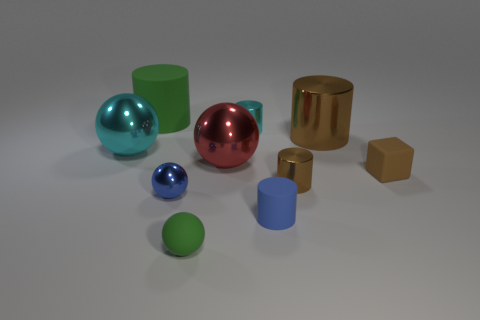What is the material of the cylinder that is to the left of the small green rubber sphere that is to the left of the small cyan metallic cylinder?
Provide a succinct answer. Rubber. Do the green object that is behind the big cyan metal object and the big cyan object have the same material?
Your answer should be compact. No. What is the size of the green matte object behind the cube?
Offer a terse response. Large. Is there a tiny green rubber sphere that is left of the shiny sphere in front of the red shiny ball?
Provide a succinct answer. No. There is a large thing that is to the right of the blue cylinder; is it the same color as the tiny ball in front of the small blue shiny object?
Offer a very short reply. No. The cube has what color?
Keep it short and to the point. Brown. Are there any other things of the same color as the rubber ball?
Your response must be concise. Yes. What color is the small thing that is both behind the tiny green matte object and in front of the blue metallic thing?
Your answer should be very brief. Blue. Does the cylinder that is on the left side of the matte ball have the same size as the large cyan object?
Keep it short and to the point. Yes. Are there more green matte spheres behind the small blue sphere than small blue metal objects?
Offer a very short reply. No. 